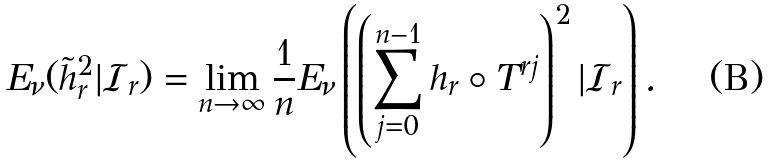<formula> <loc_0><loc_0><loc_500><loc_500>E _ { \nu } ( \tilde { h } _ { r } ^ { 2 } | \mathcal { I } _ { r } ) = \lim _ { n \to \infty } \frac { 1 } { n } E _ { \nu } \left ( \left ( \sum _ { j = 0 } ^ { n - 1 } h _ { r } \circ T ^ { r j } \right ) ^ { 2 } | \mathcal { I } _ { r } \right ) .</formula> 